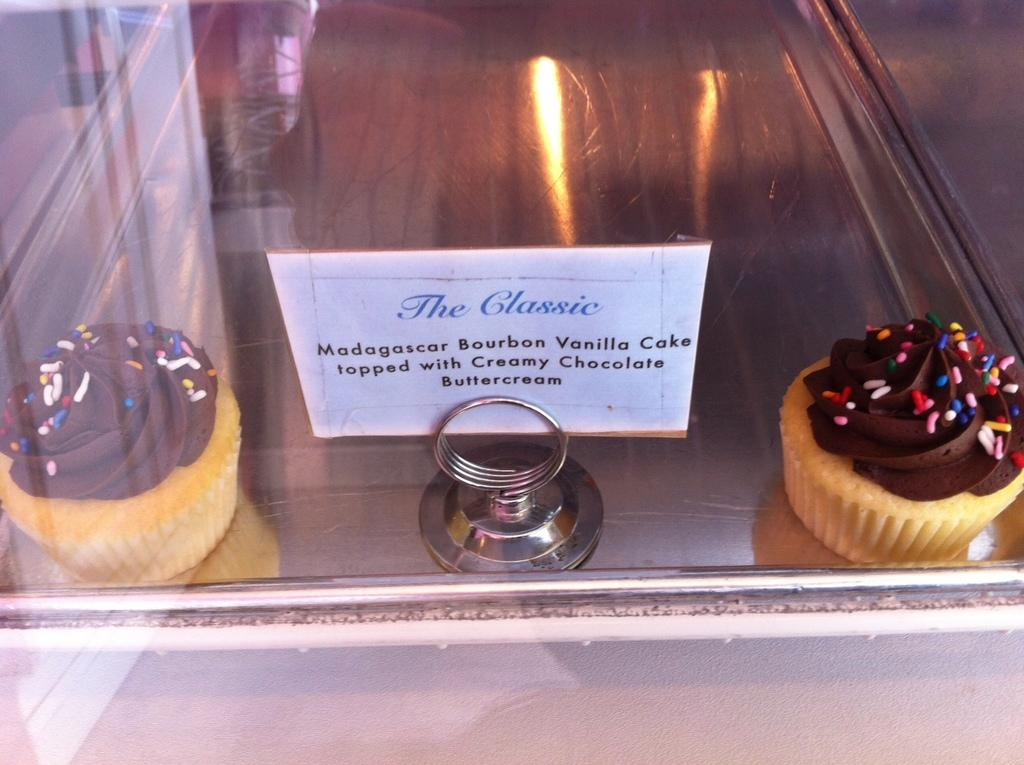What type of food can be seen in the image? There are cupcakes in the image. What structure is present in the image? There is a stand in the image. What surface is visible in the image? There is a board in the image. What source of illumination is present in the image? A: There is a light in the image. How are all these objects contained in the image? All of these objects are inside a glass box. Can you see a scarecrow standing near the river in the image? There is no scarecrow or river present in the image. Is there a fire burning inside the glass box in the image? There is no fire present in the image; the objects inside the glass box are cupcakes, a stand, a board, and a light. 